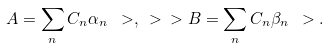Convert formula to latex. <formula><loc_0><loc_0><loc_500><loc_500>A = \sum _ { n } C _ { n } \alpha _ { n } \ > , \ > \ > B = \sum _ { n } C _ { n } \beta _ { n } \ > .</formula> 